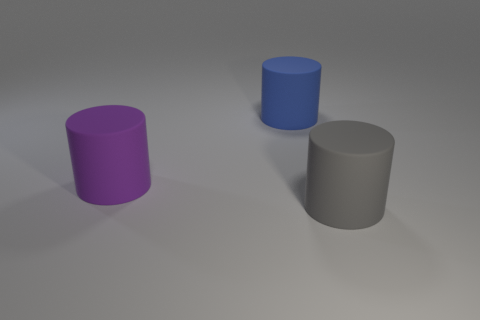How many other purple cylinders have the same size as the purple cylinder?
Your answer should be very brief. 0. What number of cyan things are either large things or large balls?
Your answer should be very brief. 0. Are there an equal number of blue objects right of the large purple cylinder and purple matte things?
Your answer should be compact. Yes. How many big purple things are the same shape as the large gray object?
Your answer should be very brief. 1. The large cylinder that is right of the big purple cylinder and in front of the big blue cylinder is made of what material?
Ensure brevity in your answer.  Rubber. What number of large blue matte things are there?
Make the answer very short. 1. What color is the thing on the right side of the big cylinder behind the big rubber cylinder that is left of the big blue cylinder?
Provide a short and direct response. Gray. What number of big matte cylinders are on the right side of the large purple rubber cylinder and behind the large gray cylinder?
Your answer should be compact. 1. What number of matte things are things or large purple objects?
Your answer should be very brief. 3. What shape is the purple rubber thing that is the same size as the blue thing?
Your answer should be compact. Cylinder. 